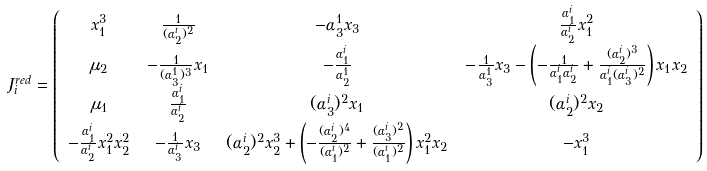<formula> <loc_0><loc_0><loc_500><loc_500>J _ { i } ^ { r e d } & = \left ( \begin{array} { c c c c } x _ { 1 } ^ { 3 } & \frac { 1 } { ( \alpha _ { 2 } ^ { i } ) ^ { 2 } } & - \alpha _ { 3 } ^ { 1 } x _ { 3 } & \frac { \alpha _ { 1 } ^ { i } } { \alpha _ { 2 } ^ { i } } x _ { 1 } ^ { 2 } \\ \mu _ { 2 } & - \frac { 1 } { ( \alpha _ { 3 } ^ { 1 } ) ^ { 3 } } x _ { 1 } & - \frac { \alpha _ { 1 } ^ { i } } { \alpha _ { 2 } ^ { 1 } } & - \frac { 1 } { \alpha _ { 3 } ^ { 1 } } x _ { 3 } - \left ( - \frac { 1 } { \alpha _ { 1 } ^ { i } \alpha _ { 2 } ^ { i } } + \frac { ( \alpha _ { 2 } ^ { i } ) ^ { 3 } } { \alpha _ { 1 } ^ { i } ( \alpha _ { 3 } ^ { i } ) ^ { 2 } } \right ) x _ { 1 } x _ { 2 } \\ \mu _ { 1 } & \frac { \alpha _ { 1 } ^ { i } } { \alpha _ { 2 } ^ { i } } & ( \alpha _ { 3 } ^ { i } ) ^ { 2 } x _ { 1 } & ( \alpha _ { 2 } ^ { i } ) ^ { 2 } x _ { 2 } \\ - \frac { \alpha _ { 1 } ^ { i } } { \alpha _ { 2 } ^ { i } } x _ { 1 } ^ { 2 } x _ { 2 } ^ { 2 } & - \frac { 1 } { \alpha _ { 3 } ^ { i } } x _ { 3 } & ( \alpha _ { 2 } ^ { i } ) ^ { 2 } x _ { 2 } ^ { 3 } + \left ( - \frac { ( \alpha _ { 2 } ^ { i } ) ^ { 4 } } { ( \alpha _ { 1 } ^ { i } ) ^ { 2 } } + \frac { ( \alpha _ { 3 } ^ { i } ) ^ { 2 } } { ( \alpha _ { 1 } ^ { i } ) ^ { 2 } } \right ) x _ { 1 } ^ { 2 } x _ { 2 } & - x _ { 1 } ^ { 3 } \end{array} \right )</formula> 